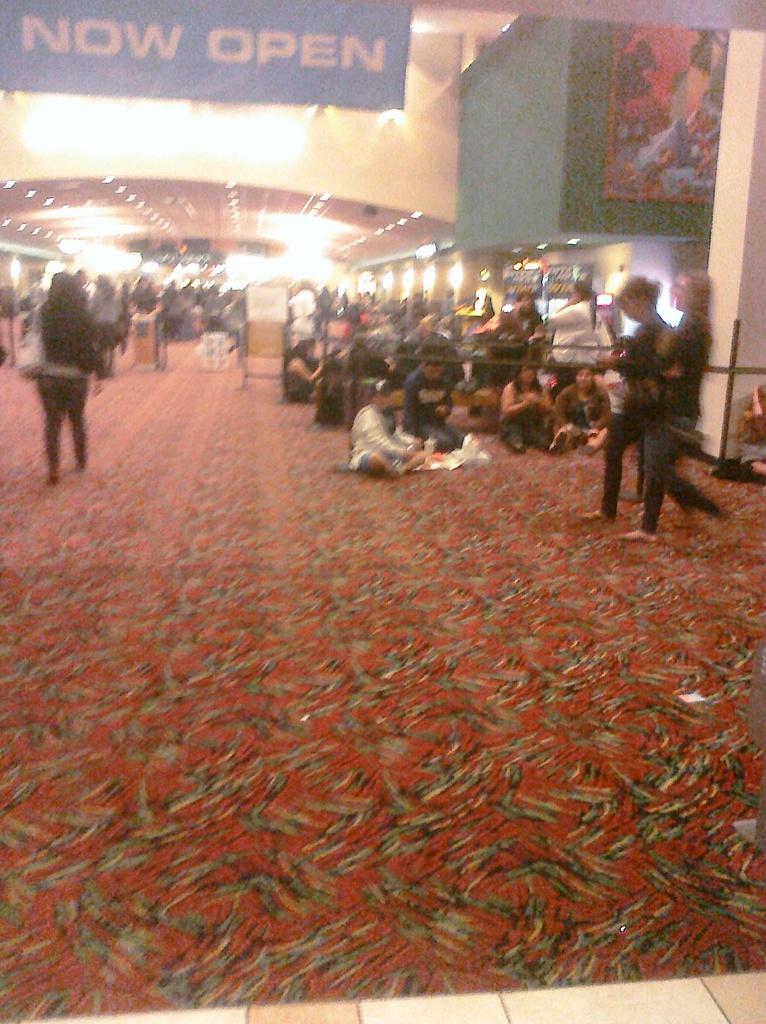How would you summarize this image in a sentence or two? In this image we can see a carpet on the floor. In the middle of the image, we can see people are standing and sitting. At the top of the image, we can see the banners and lights are attached to the roof. 